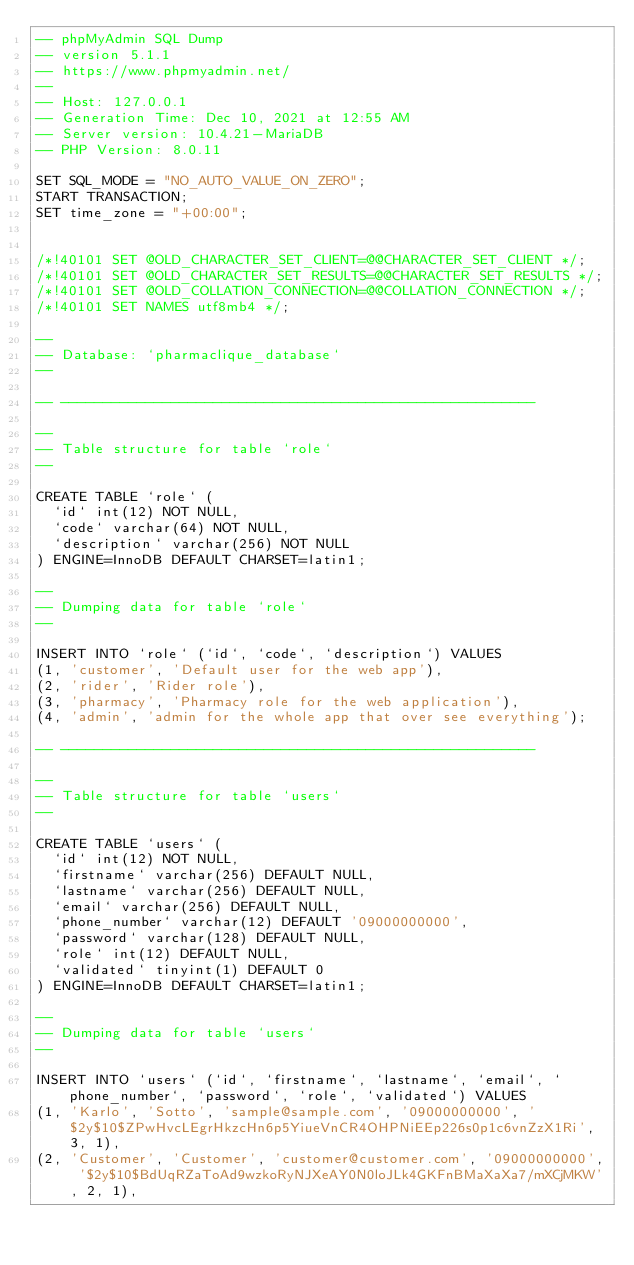<code> <loc_0><loc_0><loc_500><loc_500><_SQL_>-- phpMyAdmin SQL Dump
-- version 5.1.1
-- https://www.phpmyadmin.net/
--
-- Host: 127.0.0.1
-- Generation Time: Dec 10, 2021 at 12:55 AM
-- Server version: 10.4.21-MariaDB
-- PHP Version: 8.0.11

SET SQL_MODE = "NO_AUTO_VALUE_ON_ZERO";
START TRANSACTION;
SET time_zone = "+00:00";


/*!40101 SET @OLD_CHARACTER_SET_CLIENT=@@CHARACTER_SET_CLIENT */;
/*!40101 SET @OLD_CHARACTER_SET_RESULTS=@@CHARACTER_SET_RESULTS */;
/*!40101 SET @OLD_COLLATION_CONNECTION=@@COLLATION_CONNECTION */;
/*!40101 SET NAMES utf8mb4 */;

--
-- Database: `pharmaclique_database`
--

-- --------------------------------------------------------

--
-- Table structure for table `role`
--

CREATE TABLE `role` (
  `id` int(12) NOT NULL,
  `code` varchar(64) NOT NULL,
  `description` varchar(256) NOT NULL
) ENGINE=InnoDB DEFAULT CHARSET=latin1;

--
-- Dumping data for table `role`
--

INSERT INTO `role` (`id`, `code`, `description`) VALUES
(1, 'customer', 'Default user for the web app'),
(2, 'rider', 'Rider role'),
(3, 'pharmacy', 'Pharmacy role for the web application'),
(4, 'admin', 'admin for the whole app that over see everything');

-- --------------------------------------------------------

--
-- Table structure for table `users`
--

CREATE TABLE `users` (
  `id` int(12) NOT NULL,
  `firstname` varchar(256) DEFAULT NULL,
  `lastname` varchar(256) DEFAULT NULL,
  `email` varchar(256) DEFAULT NULL,
  `phone_number` varchar(12) DEFAULT '09000000000',
  `password` varchar(128) DEFAULT NULL,
  `role` int(12) DEFAULT NULL,
  `validated` tinyint(1) DEFAULT 0
) ENGINE=InnoDB DEFAULT CHARSET=latin1;

--
-- Dumping data for table `users`
--

INSERT INTO `users` (`id`, `firstname`, `lastname`, `email`, `phone_number`, `password`, `role`, `validated`) VALUES
(1, 'Karlo', 'Sotto', 'sample@sample.com', '09000000000', '$2y$10$ZPwHvcLEgrHkzcHn6p5YiueVnCR4OHPNiEEp226s0p1c6vnZzX1Ri', 3, 1),
(2, 'Customer', 'Customer', 'customer@customer.com', '09000000000', '$2y$10$BdUqRZaToAd9wzkoRyNJXeAY0N0loJLk4GKFnBMaXaXa7/mXCjMKW', 2, 1),</code> 